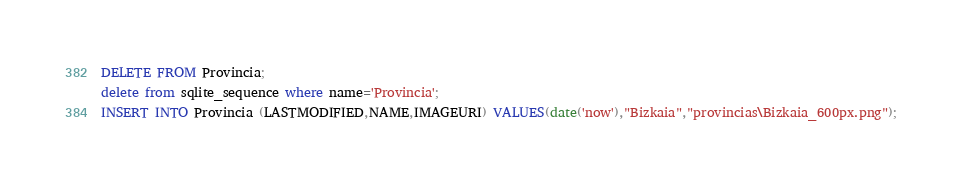<code> <loc_0><loc_0><loc_500><loc_500><_SQL_>DELETE FROM Provincia;
delete from sqlite_sequence where name='Provincia';
INSERT INTO Provincia (LASTMODIFIED,NAME,IMAGEURI) VALUES(date('now'),"Bizkaia","provincias\Bizkaia_600px.png");</code> 